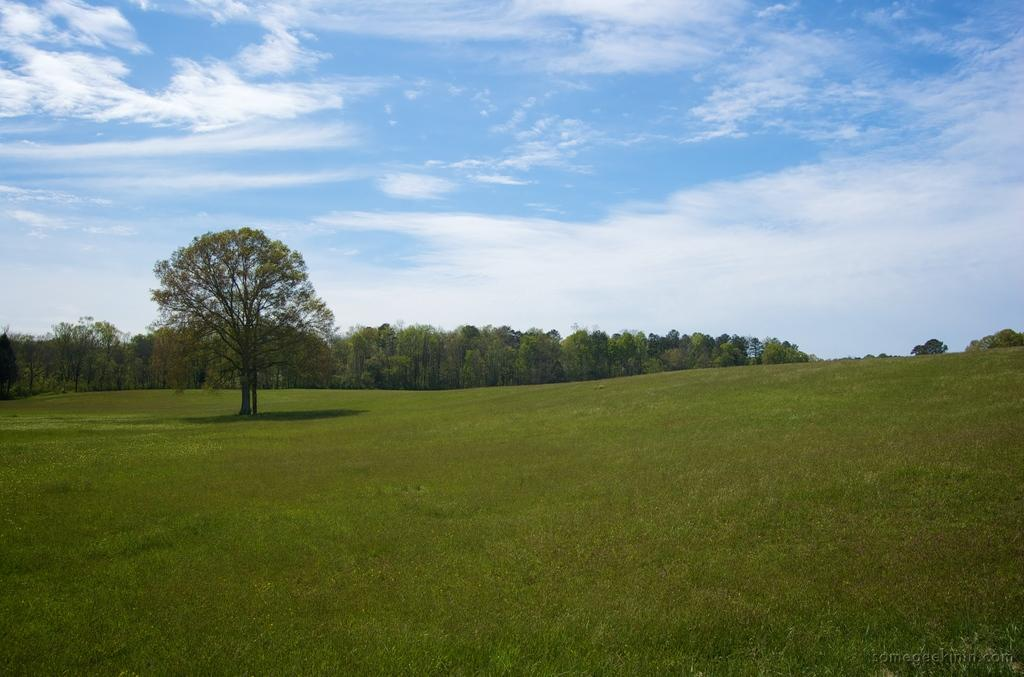What type of vegetation is visible in the image? There are trees in the image. What type of ground cover is present in the image? There is grass in the image. What part of the natural environment is visible in the image? The sky is visible in the background of the image. Where is the writer sitting with their banana and vase in the image? There is no writer, banana, or vase present in the image; it features trees, grass, and the sky. 